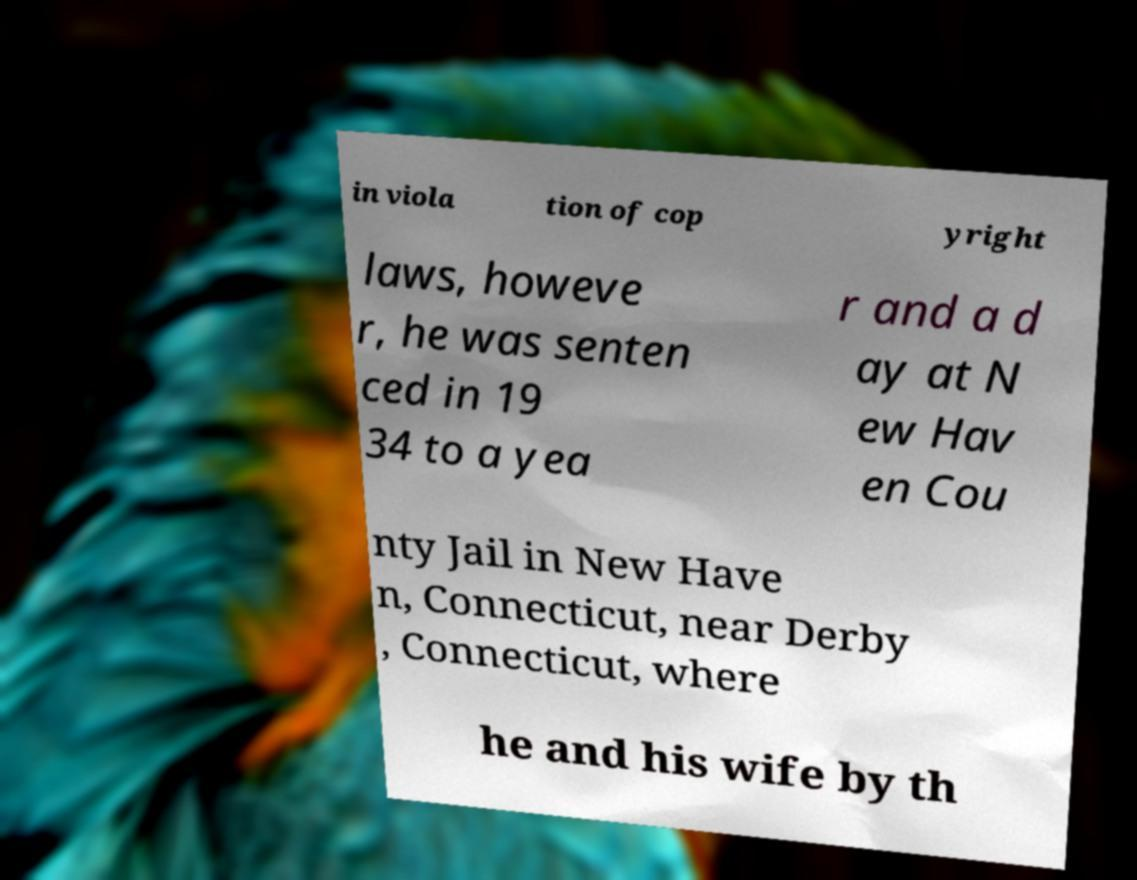Could you assist in decoding the text presented in this image and type it out clearly? in viola tion of cop yright laws, howeve r, he was senten ced in 19 34 to a yea r and a d ay at N ew Hav en Cou nty Jail in New Have n, Connecticut, near Derby , Connecticut, where he and his wife by th 